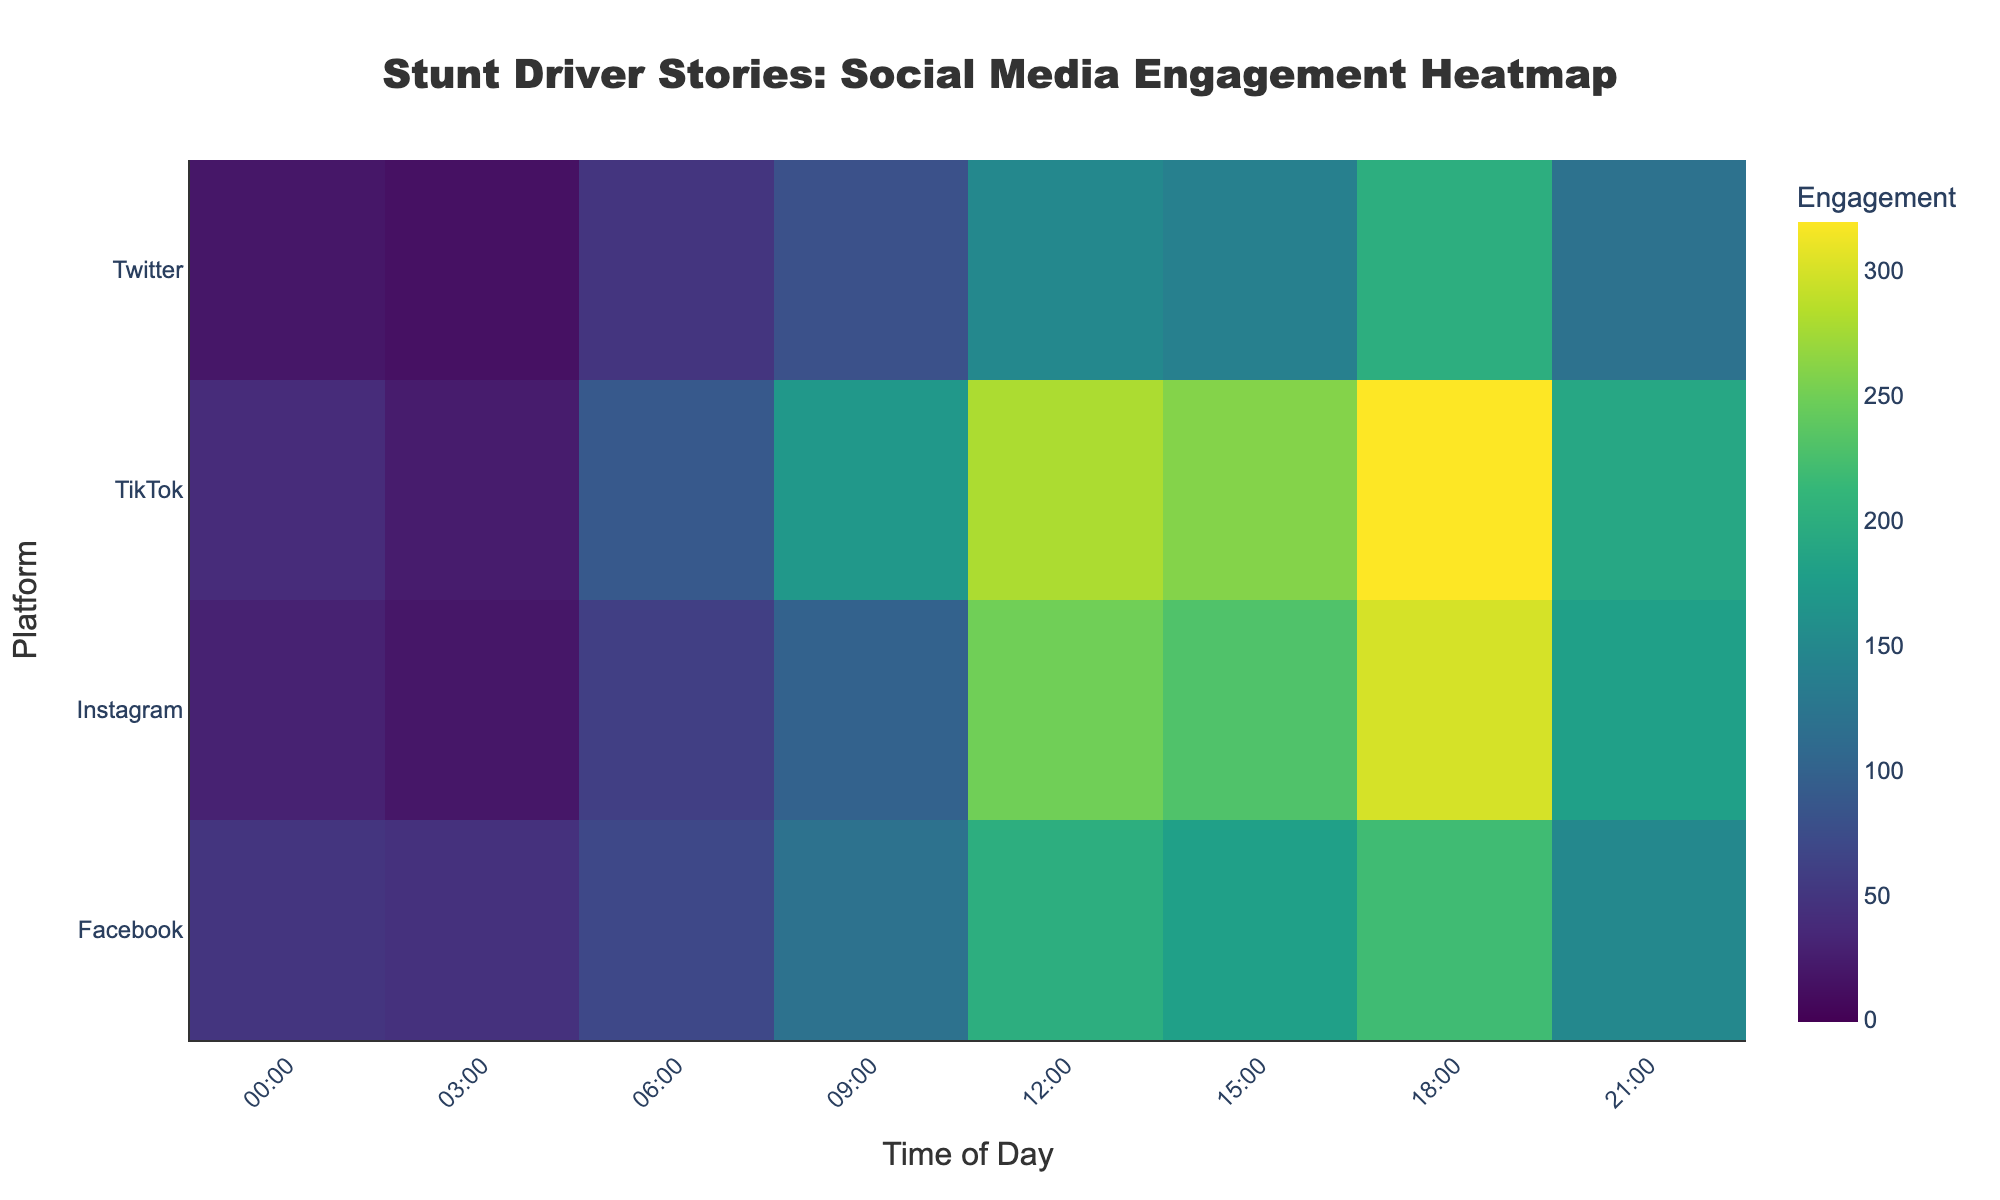What is the time of day with the highest engagement on Instagram? To find the highest engagement on Instagram, locate Instagram on the y-axis and find the time on the x-axis with the highest value. The highest value for Instagram is 300 at 18:00.
Answer: 18:00 Which platform has the highest overall engagement at 12:00? To determine this, look at the column corresponding to 12:00 and compare the values across all platforms. The highest value in this column is 280 for TikTok.
Answer: TikTok What is the engagement level on Facebook at 21:00? Check the row for Facebook and the column for 21:00 on the heatmap. The engagement level there is 150.
Answer: 150 Compare the engagement levels between TikTok and Twitter at 15:00. Which is higher? Find the row for TikTok and Twitter, then look at the engagement levels at 15:00. TikTok has 260, while Twitter has 140. TikTok's engagement is higher.
Answer: TikTok What is the average engagement for all platforms at 18:00? Locate the 18:00 column and sum the values: 220 (Facebook) + 300 (Instagram) + 200 (Twitter) + 320 (TikTok). The sum is 1040. Divide by 4 platforms to get the average (1040/4).
Answer: 260 During what time does Twitter see the lowest engagement? Check the row for Twitter and identify the lowest value, which is 15. This occurs at 03:00.
Answer: 03:00 Which platform shows the most significant increase in engagement from 03:00 to 06:00? Calculate the increase: Facebook (70 - 45 = 25), Instagram (60 - 20 = 40), Twitter (50 - 15 = 35), TikTok (90 - 25 = 65). TikTok has the highest increase of 65.
Answer: TikTok How does the engagement at 09:00 on Facebook compare to that on Instagram? Find the engagement values at 09:00 for both platforms: Facebook has 120, and Instagram has 100. Facebook's engagement is higher.
Answer: Facebook Which time of day has the least engagement overall? Sum the engagement values for all platforms at each time and find the minimum sum. 03:00 has the least sum: 45 (Facebook) + 20 (Instagram) + 15 (Twitter) + 25 (TikTok) = 105.
Answer: 03:00 